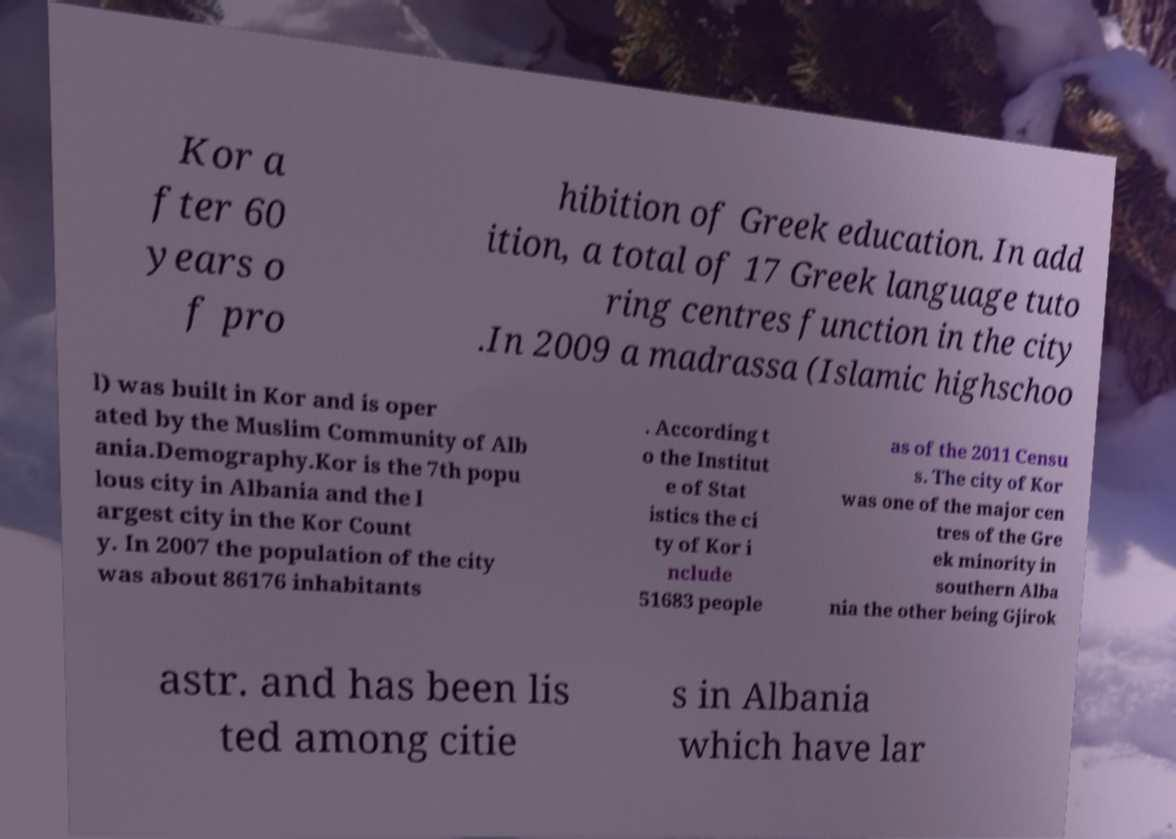There's text embedded in this image that I need extracted. Can you transcribe it verbatim? Kor a fter 60 years o f pro hibition of Greek education. In add ition, a total of 17 Greek language tuto ring centres function in the city .In 2009 a madrassa (Islamic highschoo l) was built in Kor and is oper ated by the Muslim Community of Alb ania.Demography.Kor is the 7th popu lous city in Albania and the l argest city in the Kor Count y. In 2007 the population of the city was about 86176 inhabitants . According t o the Institut e of Stat istics the ci ty of Kor i nclude 51683 people as of the 2011 Censu s. The city of Kor was one of the major cen tres of the Gre ek minority in southern Alba nia the other being Gjirok astr. and has been lis ted among citie s in Albania which have lar 